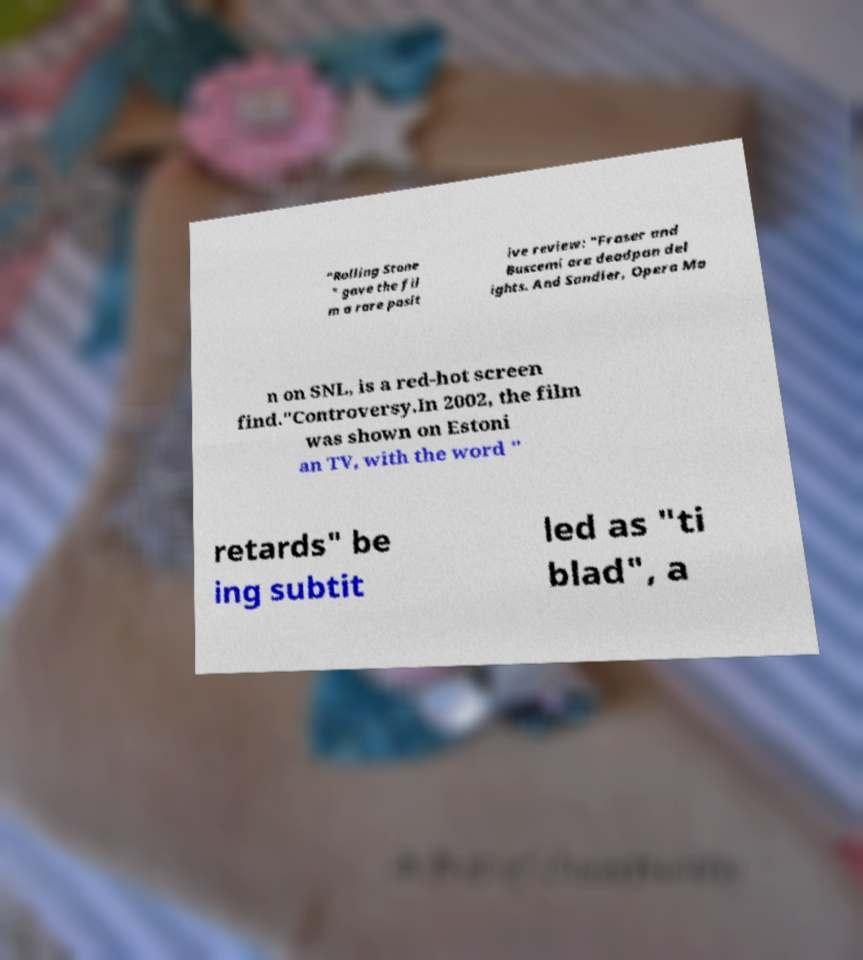I need the written content from this picture converted into text. Can you do that? "Rolling Stone " gave the fil m a rare posit ive review: "Fraser and Buscemi are deadpan del ights. And Sandler, Opera Ma n on SNL, is a red-hot screen find."Controversy.In 2002, the film was shown on Estoni an TV, with the word " retards" be ing subtit led as "ti blad", a 